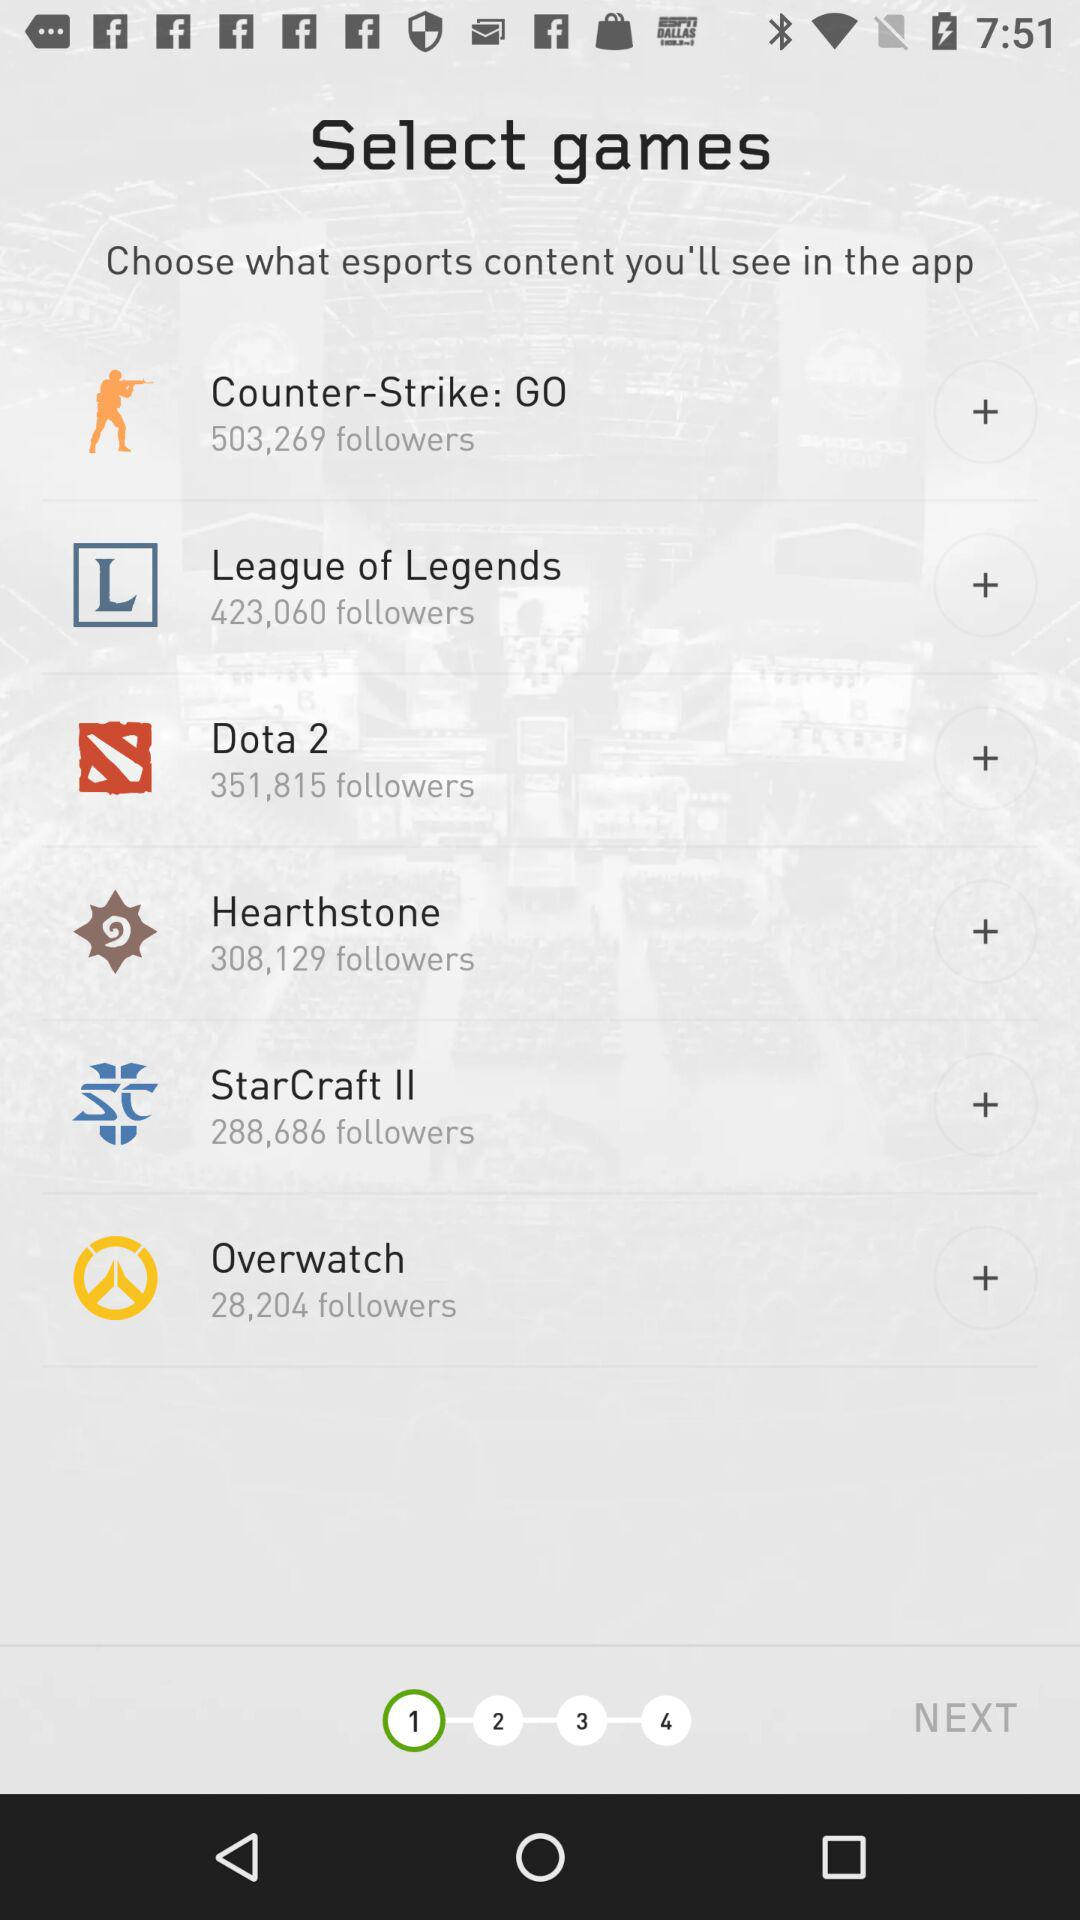How many "League of Legends" followers are there? There are 423,060 followers. 